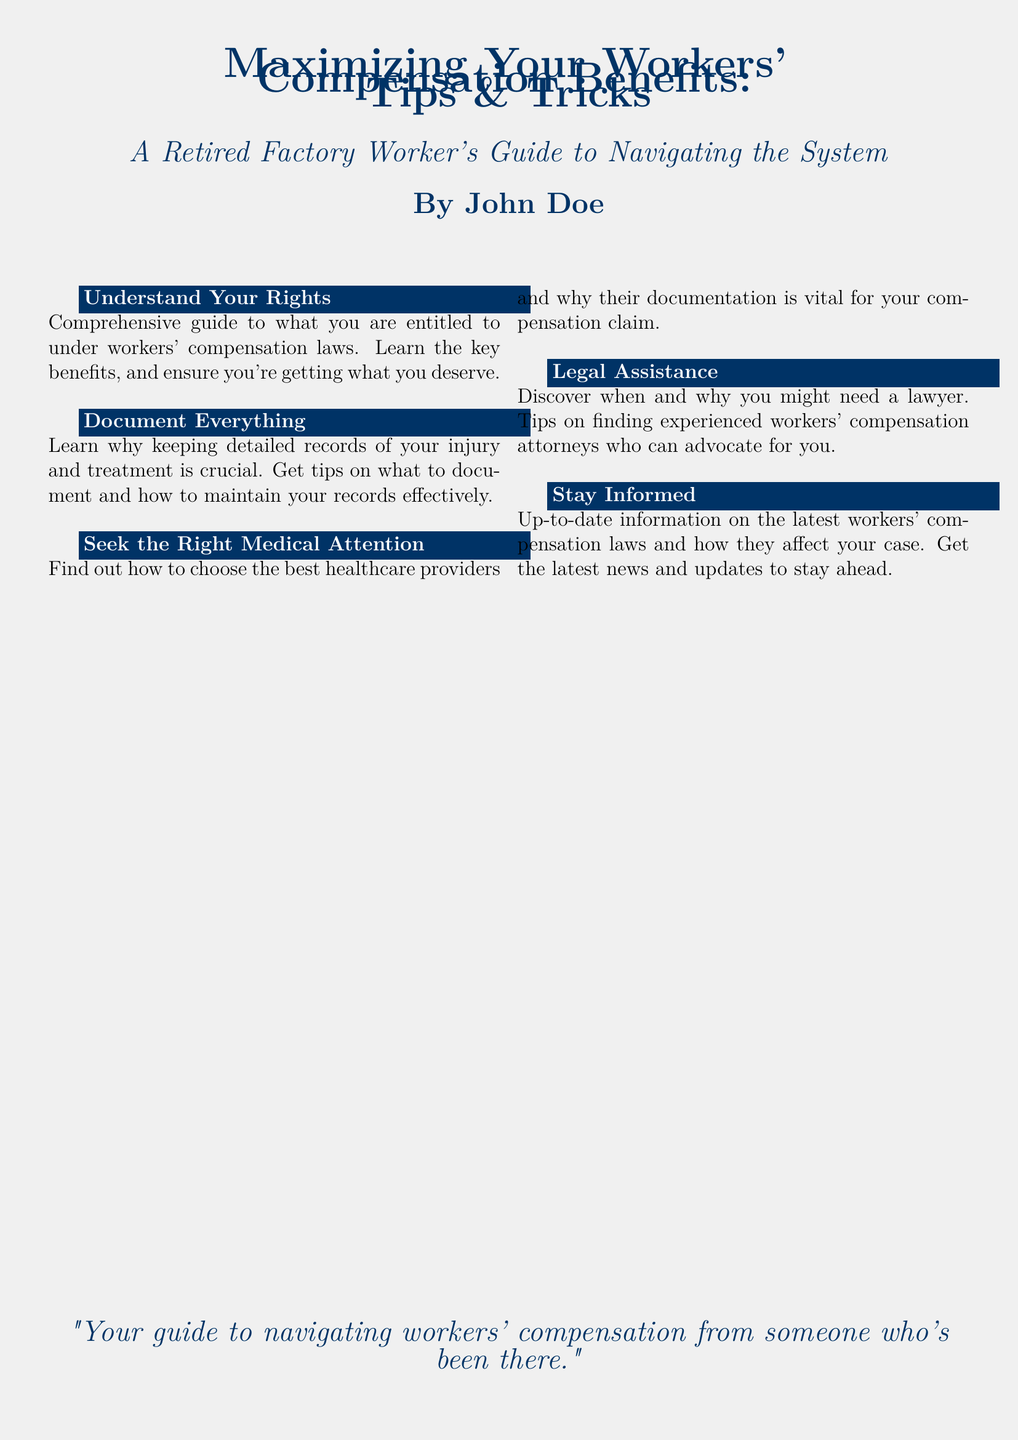What is the title of the book? The title appears prominently on the cover, stating "Maximizing Your Workers' Compensation Benefits: Tips & Tricks."
Answer: Maximizing Your Workers' Compensation Benefits: Tips & Tricks Who is the author of the book? The author's name is provided at the bottom of the cover.
Answer: John Doe What is one of the key sections in the book? The cover lists several sections, one of which is "Understand Your Rights."
Answer: Understand Your Rights What is the intended audience for the book? The subtitle indicates that it is a guide for retired factory workers or individuals navigating workers' compensation.
Answer: A Retired Factory Worker's Guide What is one reason given for documenting everything? The cover highlights the importance of keeping detailed records to aid in compensation claims.
Answer: Crucial for your compensation claim How many columns are used in the section describing tips? The layout of the tips section indicates the use of two columns.
Answer: Two What does the author emphasize about medical attention? The cover suggests that choosing the right healthcare providers is vital for compensation claims.
Answer: Vital for your compensation claim What quote is included on the cover? A quote from the book emphasizes guidance from personal experience.
Answer: "Your guide to navigating workers' compensation from someone who's been there." 